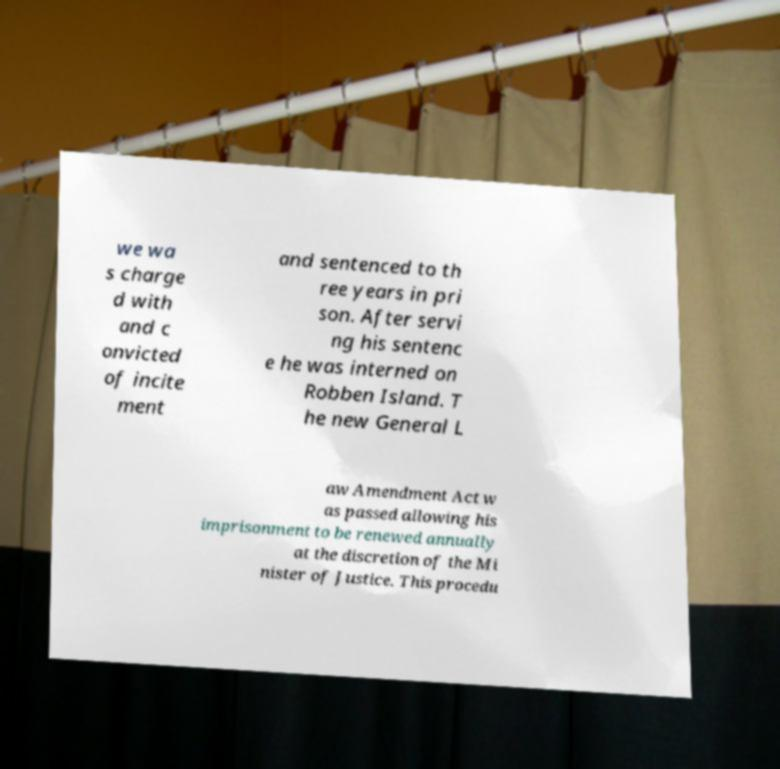Please read and relay the text visible in this image. What does it say? we wa s charge d with and c onvicted of incite ment and sentenced to th ree years in pri son. After servi ng his sentenc e he was interned on Robben Island. T he new General L aw Amendment Act w as passed allowing his imprisonment to be renewed annually at the discretion of the Mi nister of Justice. This procedu 